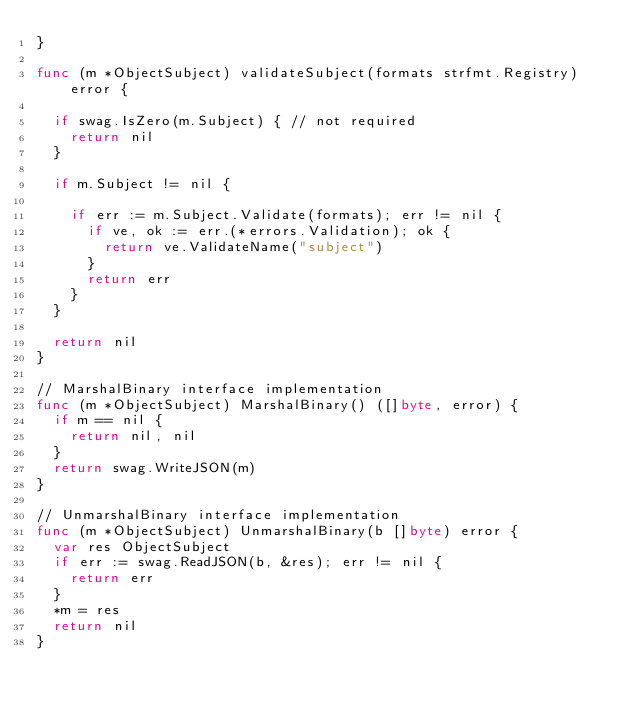Convert code to text. <code><loc_0><loc_0><loc_500><loc_500><_Go_>}

func (m *ObjectSubject) validateSubject(formats strfmt.Registry) error {

	if swag.IsZero(m.Subject) { // not required
		return nil
	}

	if m.Subject != nil {

		if err := m.Subject.Validate(formats); err != nil {
			if ve, ok := err.(*errors.Validation); ok {
				return ve.ValidateName("subject")
			}
			return err
		}
	}

	return nil
}

// MarshalBinary interface implementation
func (m *ObjectSubject) MarshalBinary() ([]byte, error) {
	if m == nil {
		return nil, nil
	}
	return swag.WriteJSON(m)
}

// UnmarshalBinary interface implementation
func (m *ObjectSubject) UnmarshalBinary(b []byte) error {
	var res ObjectSubject
	if err := swag.ReadJSON(b, &res); err != nil {
		return err
	}
	*m = res
	return nil
}
</code> 